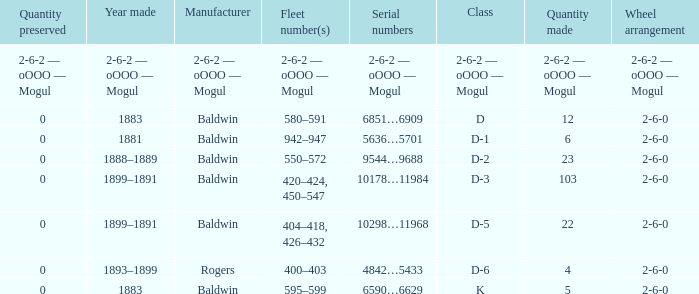What is the wheel arrangement when the year made is 1881? 2-6-0. 